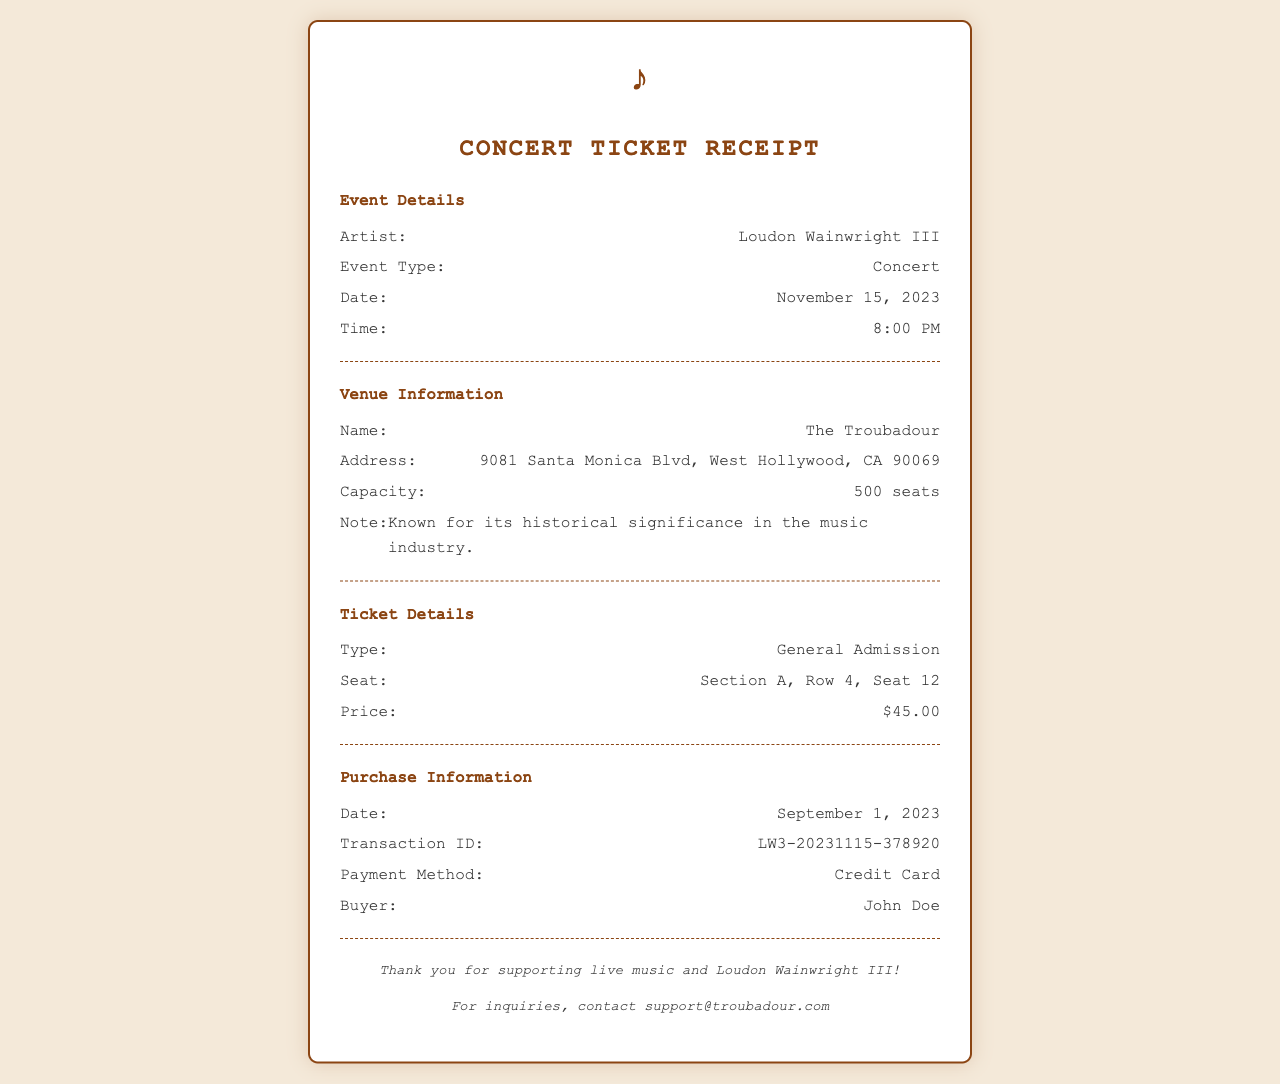What is the date of the concert? The date of the concert is specified in the document under Event Details.
Answer: November 15, 2023 What is the venue name? The venue name is mentioned in the Venue Information section of the document.
Answer: The Troubadour What is the seat number? The seat number is provided in the Ticket Details section and identifies the specific seat for the concert.
Answer: Section A, Row 4, Seat 12 How much did the ticket cost? The ticket price is clearly stated in the Ticket Details section of the receipt.
Answer: $45.00 Who is the buyer? The buyer's name is mentioned in the Purchase Information section of the document.
Answer: John Doe What is the transaction ID? The transaction ID is found in the Purchase Information and is a unique identifier for the ticket purchase.
Answer: LW3-20231115-378920 What time does the concert start? The start time of the concert is listed in the Event Details section.
Answer: 8:00 PM What is the venue's address? The venue address is found in the Venue Information section, providing the location of the concert.
Answer: 9081 Santa Monica Blvd, West Hollywood, CA 90069 What payment method was used for the purchase? The payment method is outlined in the Purchase Information section of the document.
Answer: Credit Card 